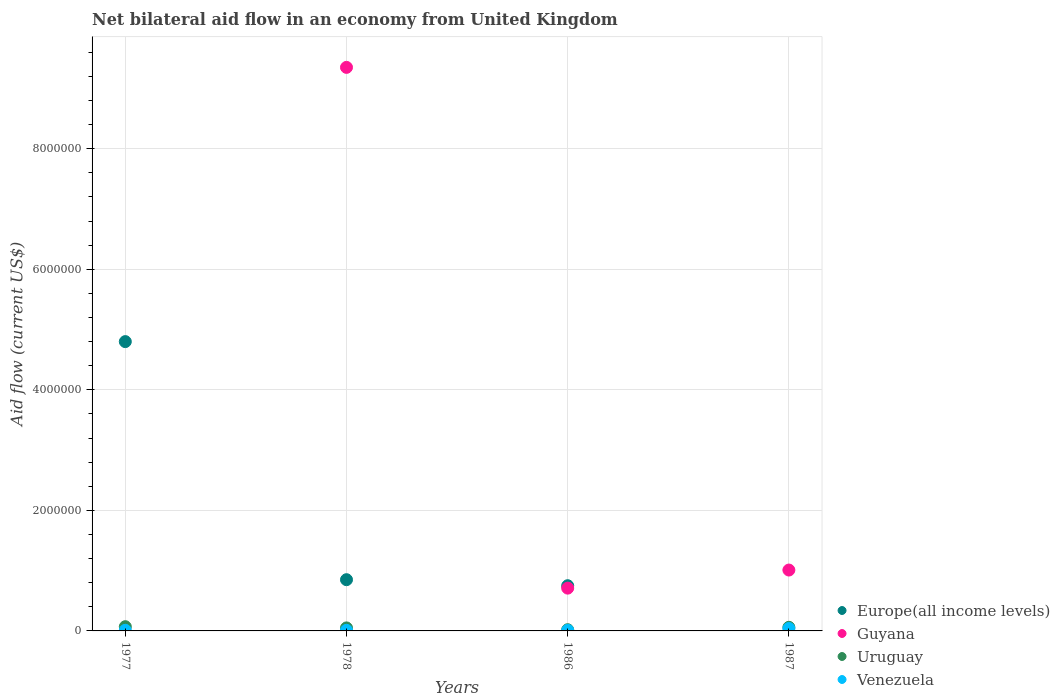How many different coloured dotlines are there?
Your answer should be compact. 4. Is the number of dotlines equal to the number of legend labels?
Your response must be concise. No. What is the net bilateral aid flow in Venezuela in 1987?
Give a very brief answer. 4.00e+04. Across all years, what is the maximum net bilateral aid flow in Europe(all income levels)?
Provide a short and direct response. 4.80e+06. Across all years, what is the minimum net bilateral aid flow in Uruguay?
Your answer should be compact. 2.00e+04. What is the total net bilateral aid flow in Guyana in the graph?
Make the answer very short. 1.11e+07. What is the difference between the net bilateral aid flow in Europe(all income levels) in 1978 and that in 1986?
Your answer should be compact. 1.00e+05. What is the difference between the net bilateral aid flow in Guyana in 1986 and the net bilateral aid flow in Uruguay in 1977?
Your response must be concise. 6.40e+05. What is the average net bilateral aid flow in Uruguay per year?
Your answer should be very brief. 5.00e+04. In the year 1986, what is the difference between the net bilateral aid flow in Venezuela and net bilateral aid flow in Uruguay?
Your answer should be very brief. -10000. What is the difference between the highest and the second highest net bilateral aid flow in Uruguay?
Make the answer very short. 10000. What is the difference between the highest and the lowest net bilateral aid flow in Europe(all income levels)?
Provide a succinct answer. 4.80e+06. Is it the case that in every year, the sum of the net bilateral aid flow in Guyana and net bilateral aid flow in Venezuela  is greater than the net bilateral aid flow in Uruguay?
Provide a short and direct response. No. Does the net bilateral aid flow in Venezuela monotonically increase over the years?
Provide a short and direct response. No. Is the net bilateral aid flow in Europe(all income levels) strictly less than the net bilateral aid flow in Venezuela over the years?
Ensure brevity in your answer.  No. How many years are there in the graph?
Ensure brevity in your answer.  4. What is the difference between two consecutive major ticks on the Y-axis?
Your answer should be compact. 2.00e+06. Are the values on the major ticks of Y-axis written in scientific E-notation?
Ensure brevity in your answer.  No. Does the graph contain any zero values?
Make the answer very short. Yes. Where does the legend appear in the graph?
Provide a succinct answer. Bottom right. How many legend labels are there?
Your answer should be compact. 4. How are the legend labels stacked?
Provide a succinct answer. Vertical. What is the title of the graph?
Offer a very short reply. Net bilateral aid flow in an economy from United Kingdom. Does "Slovak Republic" appear as one of the legend labels in the graph?
Offer a terse response. No. What is the Aid flow (current US$) of Europe(all income levels) in 1977?
Your answer should be very brief. 4.80e+06. What is the Aid flow (current US$) of Guyana in 1977?
Provide a short and direct response. 0. What is the Aid flow (current US$) of Uruguay in 1977?
Give a very brief answer. 7.00e+04. What is the Aid flow (current US$) in Europe(all income levels) in 1978?
Make the answer very short. 8.50e+05. What is the Aid flow (current US$) of Guyana in 1978?
Keep it short and to the point. 9.35e+06. What is the Aid flow (current US$) in Uruguay in 1978?
Offer a terse response. 5.00e+04. What is the Aid flow (current US$) in Europe(all income levels) in 1986?
Provide a succinct answer. 7.50e+05. What is the Aid flow (current US$) in Guyana in 1986?
Make the answer very short. 7.10e+05. What is the Aid flow (current US$) of Uruguay in 1986?
Offer a terse response. 2.00e+04. What is the Aid flow (current US$) of Venezuela in 1986?
Your answer should be very brief. 10000. What is the Aid flow (current US$) in Europe(all income levels) in 1987?
Keep it short and to the point. 0. What is the Aid flow (current US$) in Guyana in 1987?
Ensure brevity in your answer.  1.01e+06. What is the Aid flow (current US$) of Venezuela in 1987?
Provide a short and direct response. 4.00e+04. Across all years, what is the maximum Aid flow (current US$) in Europe(all income levels)?
Make the answer very short. 4.80e+06. Across all years, what is the maximum Aid flow (current US$) of Guyana?
Make the answer very short. 9.35e+06. Across all years, what is the maximum Aid flow (current US$) of Uruguay?
Give a very brief answer. 7.00e+04. Across all years, what is the maximum Aid flow (current US$) of Venezuela?
Provide a succinct answer. 4.00e+04. Across all years, what is the minimum Aid flow (current US$) in Uruguay?
Your response must be concise. 2.00e+04. What is the total Aid flow (current US$) in Europe(all income levels) in the graph?
Offer a terse response. 6.40e+06. What is the total Aid flow (current US$) of Guyana in the graph?
Keep it short and to the point. 1.11e+07. What is the total Aid flow (current US$) of Venezuela in the graph?
Provide a short and direct response. 7.00e+04. What is the difference between the Aid flow (current US$) of Europe(all income levels) in 1977 and that in 1978?
Give a very brief answer. 3.95e+06. What is the difference between the Aid flow (current US$) of Europe(all income levels) in 1977 and that in 1986?
Provide a short and direct response. 4.05e+06. What is the difference between the Aid flow (current US$) in Uruguay in 1977 and that in 1986?
Provide a succinct answer. 5.00e+04. What is the difference between the Aid flow (current US$) of Venezuela in 1977 and that in 1986?
Provide a succinct answer. 0. What is the difference between the Aid flow (current US$) in Europe(all income levels) in 1978 and that in 1986?
Your answer should be compact. 1.00e+05. What is the difference between the Aid flow (current US$) in Guyana in 1978 and that in 1986?
Your response must be concise. 8.64e+06. What is the difference between the Aid flow (current US$) in Venezuela in 1978 and that in 1986?
Your answer should be very brief. 0. What is the difference between the Aid flow (current US$) of Guyana in 1978 and that in 1987?
Offer a terse response. 8.34e+06. What is the difference between the Aid flow (current US$) in Venezuela in 1978 and that in 1987?
Your answer should be very brief. -3.00e+04. What is the difference between the Aid flow (current US$) in Guyana in 1986 and that in 1987?
Provide a succinct answer. -3.00e+05. What is the difference between the Aid flow (current US$) of Venezuela in 1986 and that in 1987?
Ensure brevity in your answer.  -3.00e+04. What is the difference between the Aid flow (current US$) in Europe(all income levels) in 1977 and the Aid flow (current US$) in Guyana in 1978?
Ensure brevity in your answer.  -4.55e+06. What is the difference between the Aid flow (current US$) of Europe(all income levels) in 1977 and the Aid flow (current US$) of Uruguay in 1978?
Offer a terse response. 4.75e+06. What is the difference between the Aid flow (current US$) of Europe(all income levels) in 1977 and the Aid flow (current US$) of Venezuela in 1978?
Make the answer very short. 4.79e+06. What is the difference between the Aid flow (current US$) in Europe(all income levels) in 1977 and the Aid flow (current US$) in Guyana in 1986?
Provide a short and direct response. 4.09e+06. What is the difference between the Aid flow (current US$) of Europe(all income levels) in 1977 and the Aid flow (current US$) of Uruguay in 1986?
Offer a terse response. 4.78e+06. What is the difference between the Aid flow (current US$) in Europe(all income levels) in 1977 and the Aid flow (current US$) in Venezuela in 1986?
Make the answer very short. 4.79e+06. What is the difference between the Aid flow (current US$) of Europe(all income levels) in 1977 and the Aid flow (current US$) of Guyana in 1987?
Make the answer very short. 3.79e+06. What is the difference between the Aid flow (current US$) of Europe(all income levels) in 1977 and the Aid flow (current US$) of Uruguay in 1987?
Offer a very short reply. 4.74e+06. What is the difference between the Aid flow (current US$) of Europe(all income levels) in 1977 and the Aid flow (current US$) of Venezuela in 1987?
Offer a very short reply. 4.76e+06. What is the difference between the Aid flow (current US$) of Uruguay in 1977 and the Aid flow (current US$) of Venezuela in 1987?
Give a very brief answer. 3.00e+04. What is the difference between the Aid flow (current US$) of Europe(all income levels) in 1978 and the Aid flow (current US$) of Uruguay in 1986?
Offer a very short reply. 8.30e+05. What is the difference between the Aid flow (current US$) of Europe(all income levels) in 1978 and the Aid flow (current US$) of Venezuela in 1986?
Offer a very short reply. 8.40e+05. What is the difference between the Aid flow (current US$) in Guyana in 1978 and the Aid flow (current US$) in Uruguay in 1986?
Provide a short and direct response. 9.33e+06. What is the difference between the Aid flow (current US$) in Guyana in 1978 and the Aid flow (current US$) in Venezuela in 1986?
Ensure brevity in your answer.  9.34e+06. What is the difference between the Aid flow (current US$) of Europe(all income levels) in 1978 and the Aid flow (current US$) of Guyana in 1987?
Your response must be concise. -1.60e+05. What is the difference between the Aid flow (current US$) of Europe(all income levels) in 1978 and the Aid flow (current US$) of Uruguay in 1987?
Provide a short and direct response. 7.90e+05. What is the difference between the Aid flow (current US$) of Europe(all income levels) in 1978 and the Aid flow (current US$) of Venezuela in 1987?
Offer a terse response. 8.10e+05. What is the difference between the Aid flow (current US$) of Guyana in 1978 and the Aid flow (current US$) of Uruguay in 1987?
Offer a very short reply. 9.29e+06. What is the difference between the Aid flow (current US$) in Guyana in 1978 and the Aid flow (current US$) in Venezuela in 1987?
Ensure brevity in your answer.  9.31e+06. What is the difference between the Aid flow (current US$) in Europe(all income levels) in 1986 and the Aid flow (current US$) in Guyana in 1987?
Your answer should be compact. -2.60e+05. What is the difference between the Aid flow (current US$) in Europe(all income levels) in 1986 and the Aid flow (current US$) in Uruguay in 1987?
Give a very brief answer. 6.90e+05. What is the difference between the Aid flow (current US$) in Europe(all income levels) in 1986 and the Aid flow (current US$) in Venezuela in 1987?
Make the answer very short. 7.10e+05. What is the difference between the Aid flow (current US$) of Guyana in 1986 and the Aid flow (current US$) of Uruguay in 1987?
Provide a short and direct response. 6.50e+05. What is the difference between the Aid flow (current US$) of Guyana in 1986 and the Aid flow (current US$) of Venezuela in 1987?
Make the answer very short. 6.70e+05. What is the average Aid flow (current US$) in Europe(all income levels) per year?
Offer a very short reply. 1.60e+06. What is the average Aid flow (current US$) of Guyana per year?
Your answer should be compact. 2.77e+06. What is the average Aid flow (current US$) of Uruguay per year?
Keep it short and to the point. 5.00e+04. What is the average Aid flow (current US$) in Venezuela per year?
Make the answer very short. 1.75e+04. In the year 1977, what is the difference between the Aid flow (current US$) of Europe(all income levels) and Aid flow (current US$) of Uruguay?
Provide a short and direct response. 4.73e+06. In the year 1977, what is the difference between the Aid flow (current US$) in Europe(all income levels) and Aid flow (current US$) in Venezuela?
Offer a terse response. 4.79e+06. In the year 1977, what is the difference between the Aid flow (current US$) of Uruguay and Aid flow (current US$) of Venezuela?
Your response must be concise. 6.00e+04. In the year 1978, what is the difference between the Aid flow (current US$) in Europe(all income levels) and Aid flow (current US$) in Guyana?
Offer a terse response. -8.50e+06. In the year 1978, what is the difference between the Aid flow (current US$) in Europe(all income levels) and Aid flow (current US$) in Uruguay?
Make the answer very short. 8.00e+05. In the year 1978, what is the difference between the Aid flow (current US$) of Europe(all income levels) and Aid flow (current US$) of Venezuela?
Your answer should be compact. 8.40e+05. In the year 1978, what is the difference between the Aid flow (current US$) of Guyana and Aid flow (current US$) of Uruguay?
Keep it short and to the point. 9.30e+06. In the year 1978, what is the difference between the Aid flow (current US$) of Guyana and Aid flow (current US$) of Venezuela?
Offer a very short reply. 9.34e+06. In the year 1978, what is the difference between the Aid flow (current US$) in Uruguay and Aid flow (current US$) in Venezuela?
Ensure brevity in your answer.  4.00e+04. In the year 1986, what is the difference between the Aid flow (current US$) of Europe(all income levels) and Aid flow (current US$) of Guyana?
Give a very brief answer. 4.00e+04. In the year 1986, what is the difference between the Aid flow (current US$) of Europe(all income levels) and Aid flow (current US$) of Uruguay?
Keep it short and to the point. 7.30e+05. In the year 1986, what is the difference between the Aid flow (current US$) in Europe(all income levels) and Aid flow (current US$) in Venezuela?
Your answer should be very brief. 7.40e+05. In the year 1986, what is the difference between the Aid flow (current US$) in Guyana and Aid flow (current US$) in Uruguay?
Offer a very short reply. 6.90e+05. In the year 1986, what is the difference between the Aid flow (current US$) of Guyana and Aid flow (current US$) of Venezuela?
Give a very brief answer. 7.00e+05. In the year 1986, what is the difference between the Aid flow (current US$) in Uruguay and Aid flow (current US$) in Venezuela?
Offer a very short reply. 10000. In the year 1987, what is the difference between the Aid flow (current US$) in Guyana and Aid flow (current US$) in Uruguay?
Ensure brevity in your answer.  9.50e+05. In the year 1987, what is the difference between the Aid flow (current US$) of Guyana and Aid flow (current US$) of Venezuela?
Your response must be concise. 9.70e+05. What is the ratio of the Aid flow (current US$) in Europe(all income levels) in 1977 to that in 1978?
Your answer should be very brief. 5.65. What is the ratio of the Aid flow (current US$) in Uruguay in 1977 to that in 1978?
Your response must be concise. 1.4. What is the ratio of the Aid flow (current US$) of Venezuela in 1977 to that in 1978?
Keep it short and to the point. 1. What is the ratio of the Aid flow (current US$) of Europe(all income levels) in 1977 to that in 1986?
Your answer should be compact. 6.4. What is the ratio of the Aid flow (current US$) in Venezuela in 1977 to that in 1987?
Your answer should be compact. 0.25. What is the ratio of the Aid flow (current US$) of Europe(all income levels) in 1978 to that in 1986?
Offer a very short reply. 1.13. What is the ratio of the Aid flow (current US$) in Guyana in 1978 to that in 1986?
Provide a short and direct response. 13.17. What is the ratio of the Aid flow (current US$) in Uruguay in 1978 to that in 1986?
Offer a terse response. 2.5. What is the ratio of the Aid flow (current US$) of Guyana in 1978 to that in 1987?
Keep it short and to the point. 9.26. What is the ratio of the Aid flow (current US$) of Uruguay in 1978 to that in 1987?
Provide a short and direct response. 0.83. What is the ratio of the Aid flow (current US$) in Guyana in 1986 to that in 1987?
Your answer should be very brief. 0.7. What is the ratio of the Aid flow (current US$) of Uruguay in 1986 to that in 1987?
Give a very brief answer. 0.33. What is the difference between the highest and the second highest Aid flow (current US$) of Europe(all income levels)?
Provide a succinct answer. 3.95e+06. What is the difference between the highest and the second highest Aid flow (current US$) in Guyana?
Offer a very short reply. 8.34e+06. What is the difference between the highest and the second highest Aid flow (current US$) of Venezuela?
Your answer should be very brief. 3.00e+04. What is the difference between the highest and the lowest Aid flow (current US$) in Europe(all income levels)?
Your answer should be compact. 4.80e+06. What is the difference between the highest and the lowest Aid flow (current US$) in Guyana?
Your response must be concise. 9.35e+06. 